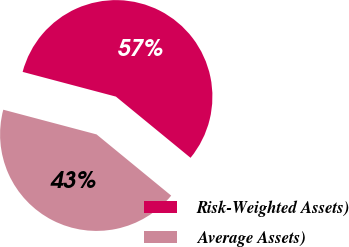Convert chart. <chart><loc_0><loc_0><loc_500><loc_500><pie_chart><fcel>Risk-Weighted Assets)<fcel>Average Assets)<nl><fcel>56.81%<fcel>43.19%<nl></chart> 